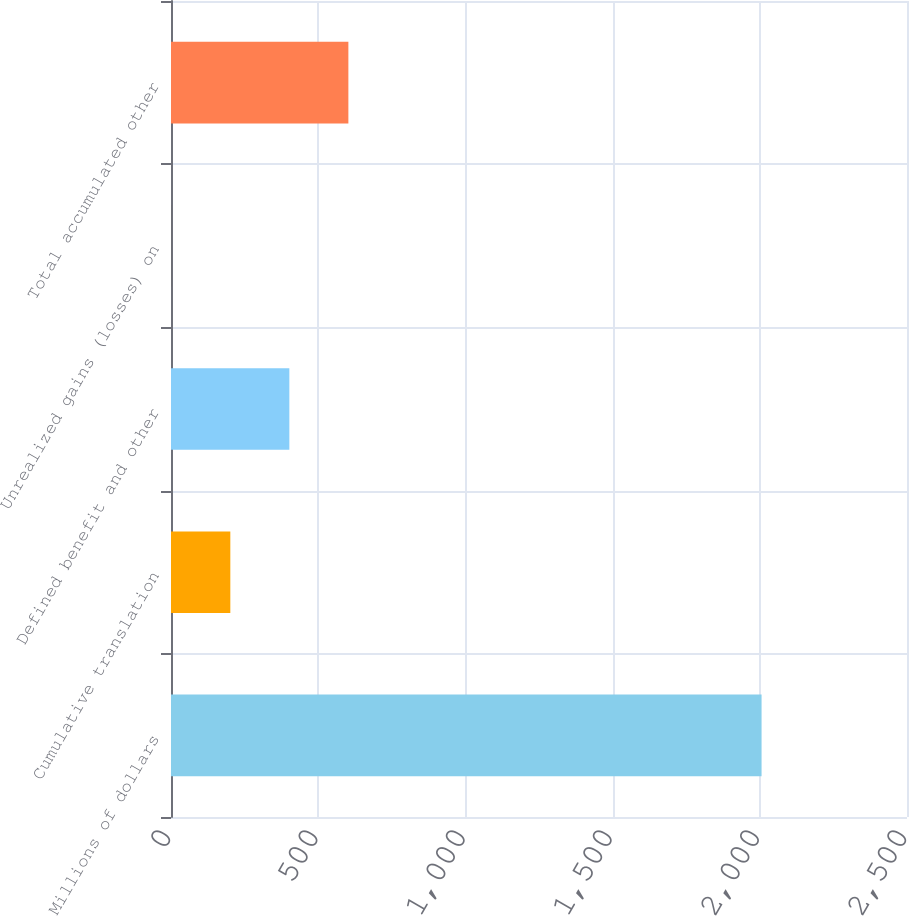<chart> <loc_0><loc_0><loc_500><loc_500><bar_chart><fcel>Millions of dollars<fcel>Cumulative translation<fcel>Defined benefit and other<fcel>Unrealized gains (losses) on<fcel>Total accumulated other<nl><fcel>2006<fcel>201.5<fcel>402<fcel>1<fcel>602.5<nl></chart> 